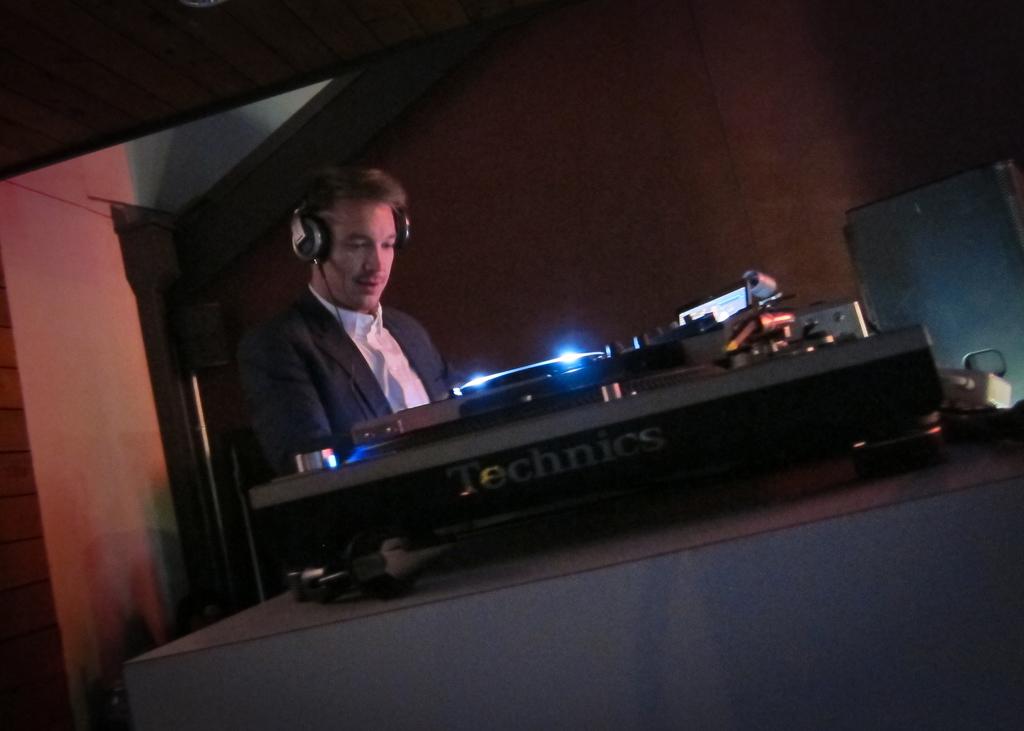What is the brand of the mixer?
Make the answer very short. Technics. 